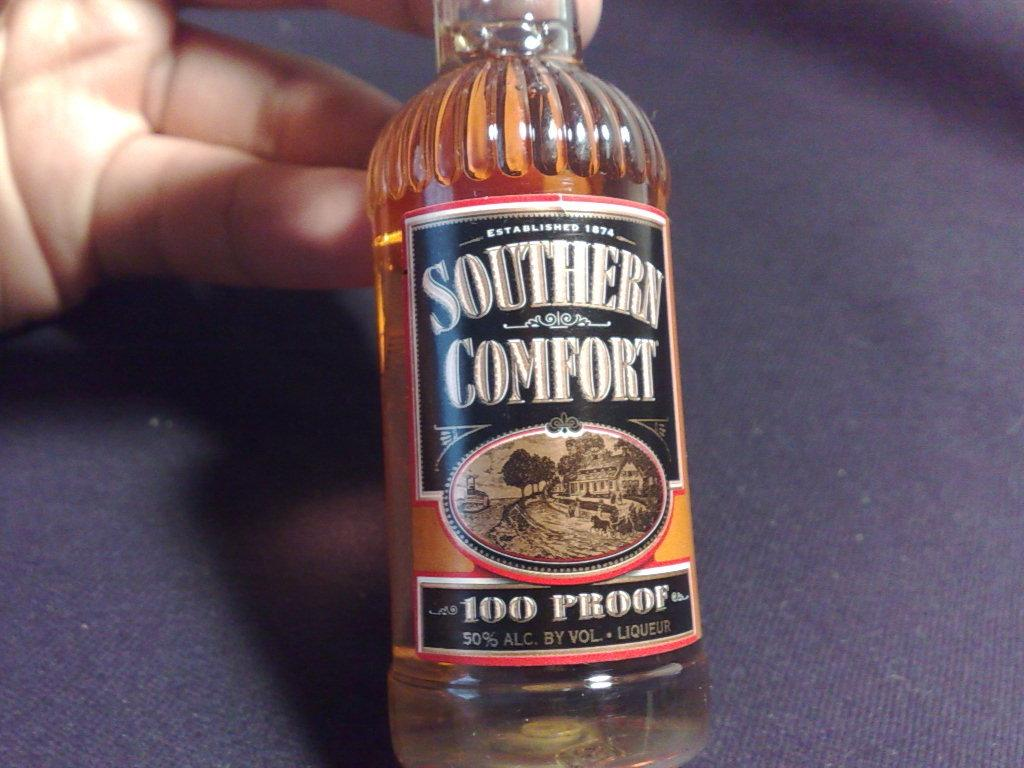<image>
Relay a brief, clear account of the picture shown. A small bottle of 100 proof alcohol made by southern comfort 